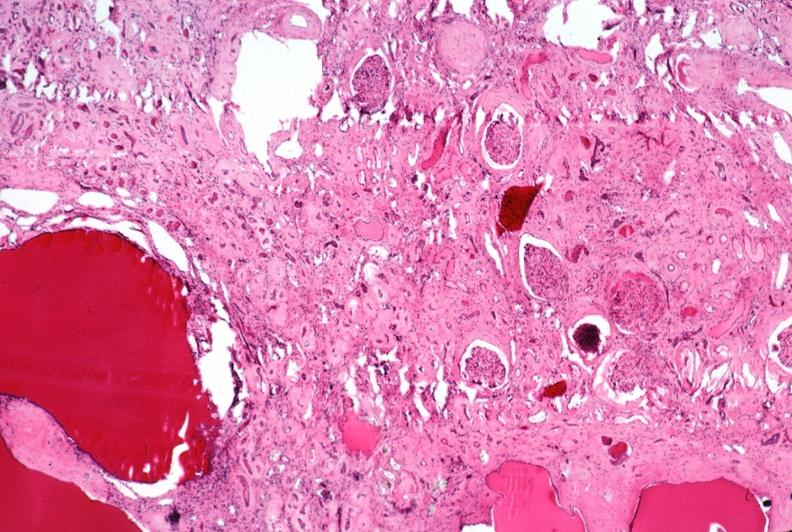does that show kidney, adult polycystic kidney?
Answer the question using a single word or phrase. No 